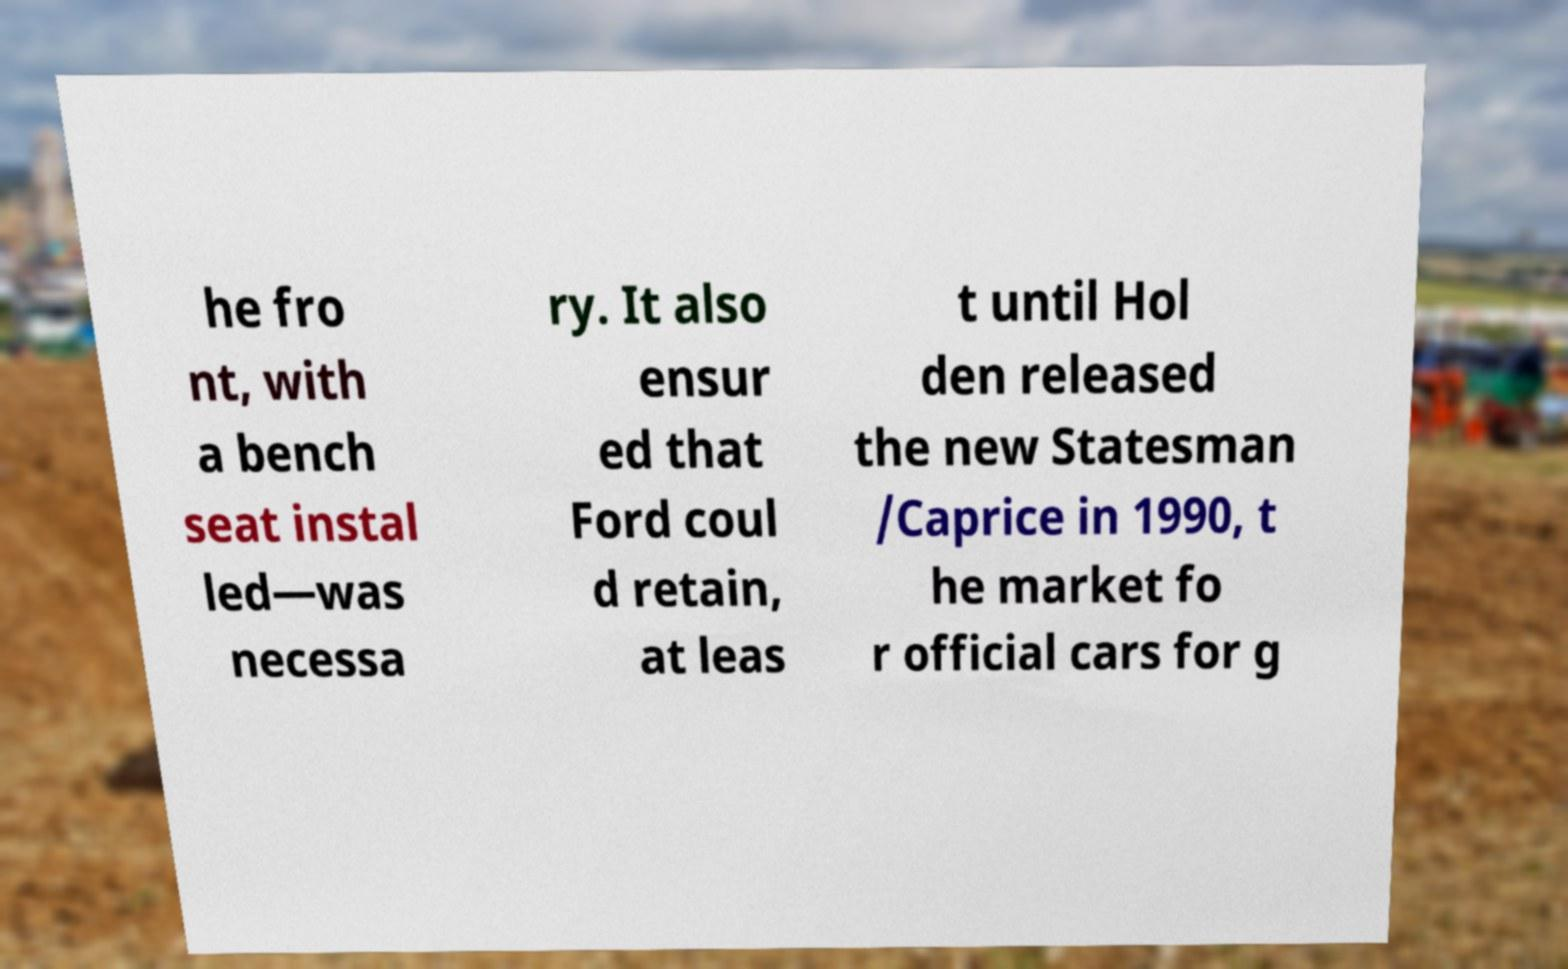I need the written content from this picture converted into text. Can you do that? he fro nt, with a bench seat instal led—was necessa ry. It also ensur ed that Ford coul d retain, at leas t until Hol den released the new Statesman /Caprice in 1990, t he market fo r official cars for g 